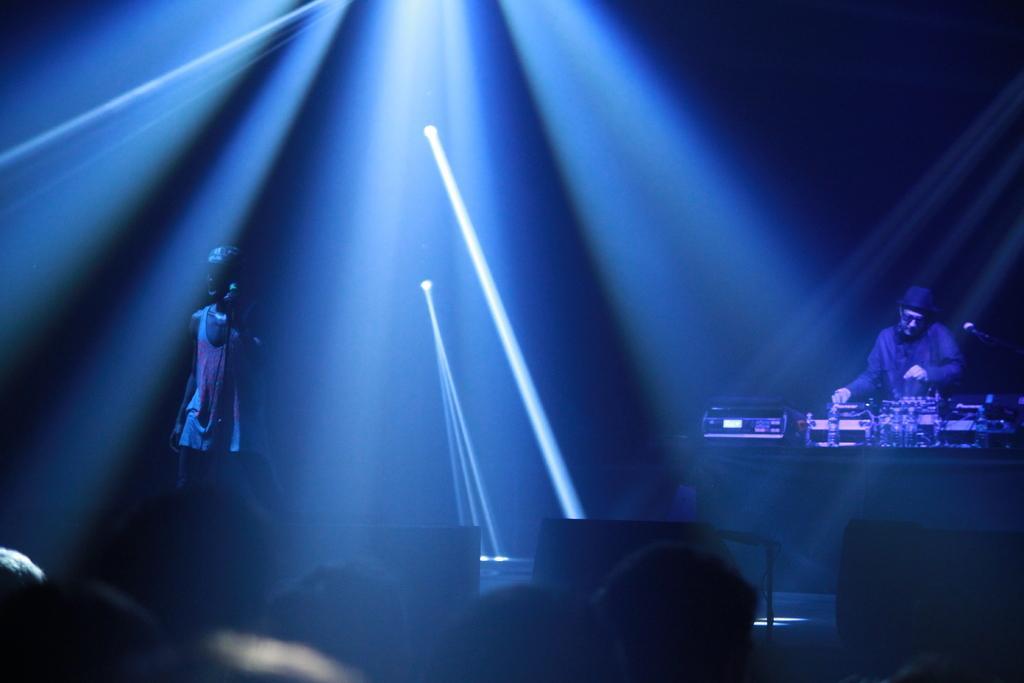How would you summarize this image in a sentence or two? In the picture it looks like some concert, there is a person standing on the dais and behind him another person is playing the music, the crowd is standing in front of the dais and there is a blue light focusing everywhere. 